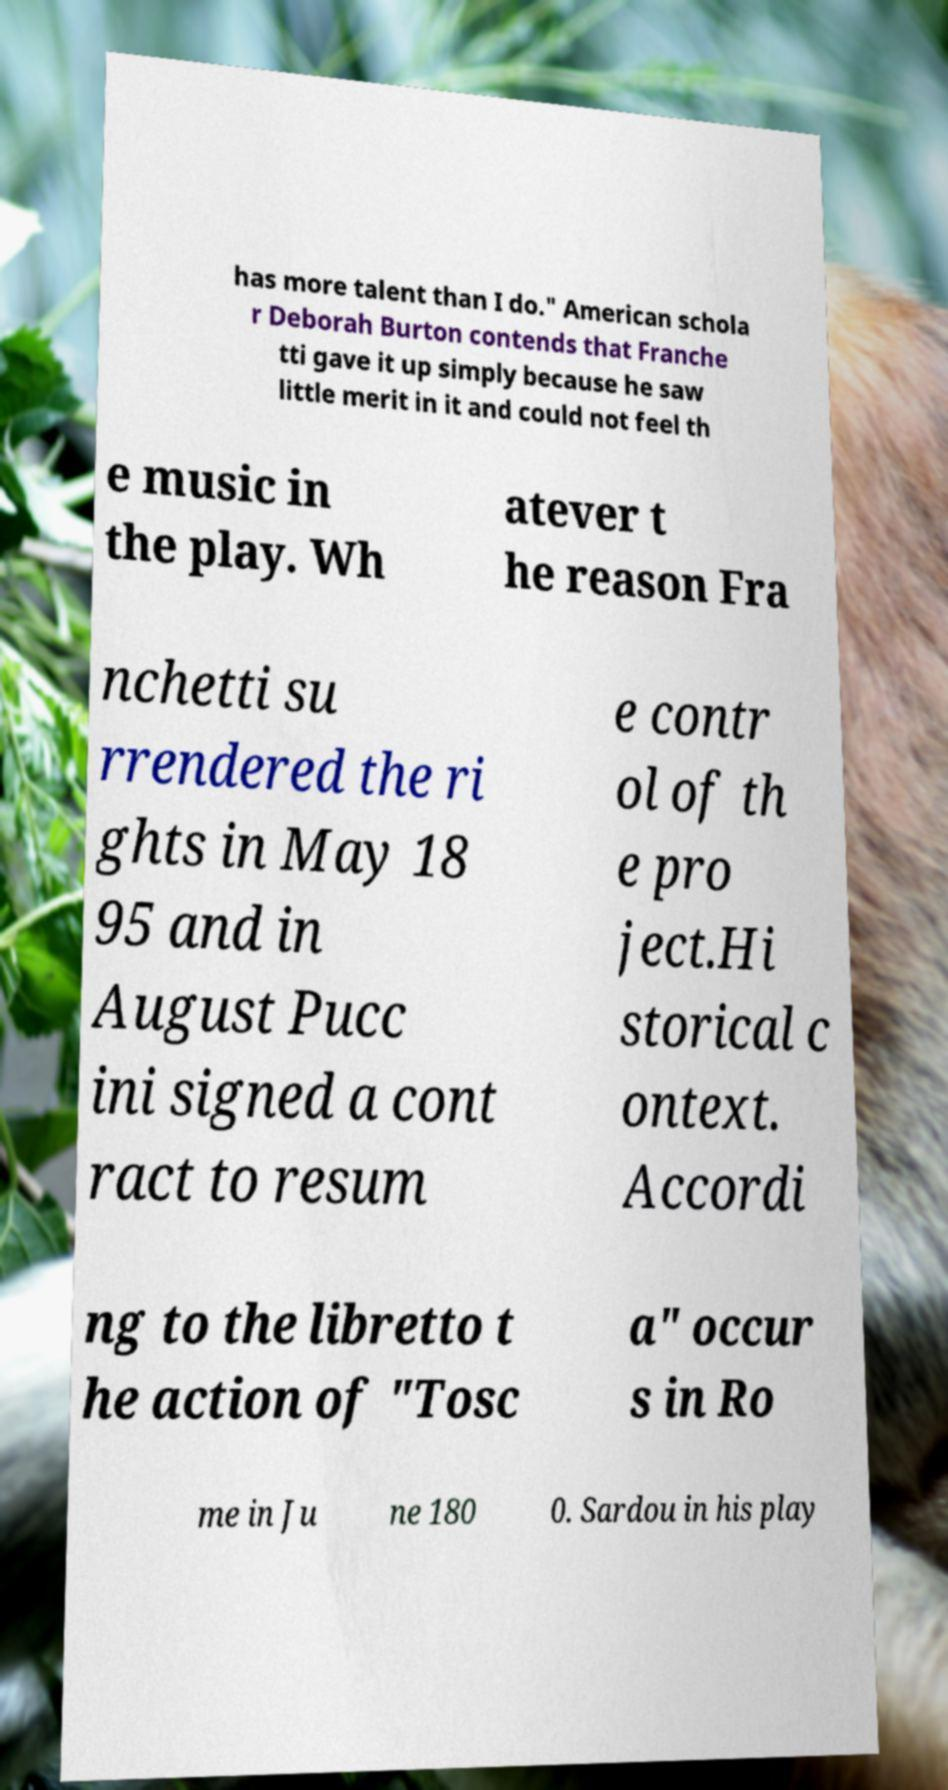For documentation purposes, I need the text within this image transcribed. Could you provide that? has more talent than I do." American schola r Deborah Burton contends that Franche tti gave it up simply because he saw little merit in it and could not feel th e music in the play. Wh atever t he reason Fra nchetti su rrendered the ri ghts in May 18 95 and in August Pucc ini signed a cont ract to resum e contr ol of th e pro ject.Hi storical c ontext. Accordi ng to the libretto t he action of "Tosc a" occur s in Ro me in Ju ne 180 0. Sardou in his play 